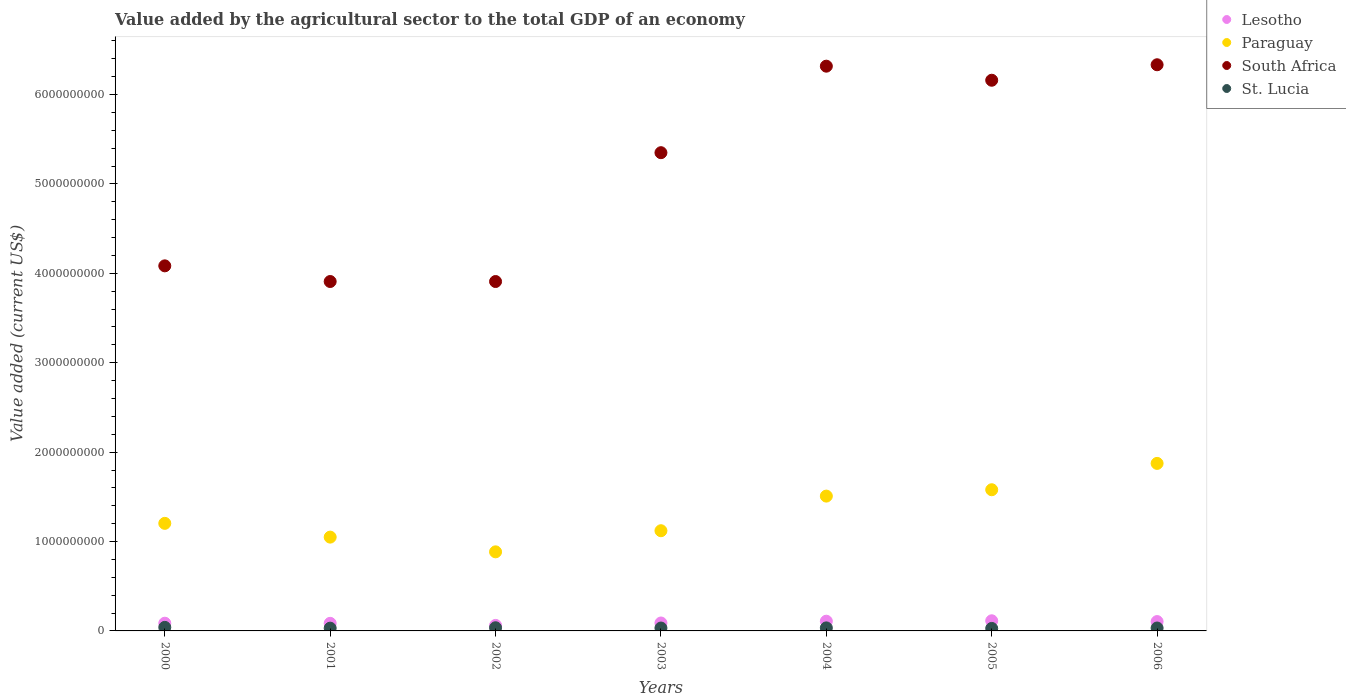Is the number of dotlines equal to the number of legend labels?
Give a very brief answer. Yes. What is the value added by the agricultural sector to the total GDP in St. Lucia in 2003?
Ensure brevity in your answer.  3.23e+07. Across all years, what is the maximum value added by the agricultural sector to the total GDP in Lesotho?
Provide a succinct answer. 1.13e+08. Across all years, what is the minimum value added by the agricultural sector to the total GDP in Lesotho?
Ensure brevity in your answer.  6.17e+07. What is the total value added by the agricultural sector to the total GDP in St. Lucia in the graph?
Keep it short and to the point. 2.33e+08. What is the difference between the value added by the agricultural sector to the total GDP in Lesotho in 2002 and that in 2005?
Your answer should be compact. -5.17e+07. What is the difference between the value added by the agricultural sector to the total GDP in Lesotho in 2002 and the value added by the agricultural sector to the total GDP in Paraguay in 2001?
Offer a terse response. -9.88e+08. What is the average value added by the agricultural sector to the total GDP in Lesotho per year?
Your answer should be very brief. 9.26e+07. In the year 2006, what is the difference between the value added by the agricultural sector to the total GDP in St. Lucia and value added by the agricultural sector to the total GDP in Lesotho?
Provide a short and direct response. -7.21e+07. In how many years, is the value added by the agricultural sector to the total GDP in Lesotho greater than 400000000 US$?
Provide a short and direct response. 0. What is the ratio of the value added by the agricultural sector to the total GDP in Lesotho in 2002 to that in 2003?
Offer a terse response. 0.7. What is the difference between the highest and the second highest value added by the agricultural sector to the total GDP in Paraguay?
Make the answer very short. 2.95e+08. What is the difference between the highest and the lowest value added by the agricultural sector to the total GDP in St. Lucia?
Your answer should be compact. 1.18e+07. In how many years, is the value added by the agricultural sector to the total GDP in St. Lucia greater than the average value added by the agricultural sector to the total GDP in St. Lucia taken over all years?
Make the answer very short. 3. Is the sum of the value added by the agricultural sector to the total GDP in St. Lucia in 2003 and 2006 greater than the maximum value added by the agricultural sector to the total GDP in South Africa across all years?
Keep it short and to the point. No. Is the value added by the agricultural sector to the total GDP in South Africa strictly less than the value added by the agricultural sector to the total GDP in Lesotho over the years?
Your answer should be compact. No. How many dotlines are there?
Your response must be concise. 4. Are the values on the major ticks of Y-axis written in scientific E-notation?
Keep it short and to the point. No. Does the graph contain grids?
Make the answer very short. No. What is the title of the graph?
Ensure brevity in your answer.  Value added by the agricultural sector to the total GDP of an economy. Does "Angola" appear as one of the legend labels in the graph?
Offer a terse response. No. What is the label or title of the Y-axis?
Offer a very short reply. Value added (current US$). What is the Value added (current US$) of Lesotho in 2000?
Provide a short and direct response. 8.62e+07. What is the Value added (current US$) of Paraguay in 2000?
Keep it short and to the point. 1.20e+09. What is the Value added (current US$) of South Africa in 2000?
Offer a terse response. 4.08e+09. What is the Value added (current US$) of St. Lucia in 2000?
Make the answer very short. 3.98e+07. What is the Value added (current US$) of Lesotho in 2001?
Provide a short and direct response. 8.49e+07. What is the Value added (current US$) of Paraguay in 2001?
Offer a terse response. 1.05e+09. What is the Value added (current US$) of South Africa in 2001?
Provide a succinct answer. 3.91e+09. What is the Value added (current US$) of St. Lucia in 2001?
Give a very brief answer. 3.09e+07. What is the Value added (current US$) in Lesotho in 2002?
Keep it short and to the point. 6.17e+07. What is the Value added (current US$) in Paraguay in 2002?
Your answer should be compact. 8.85e+08. What is the Value added (current US$) of South Africa in 2002?
Offer a terse response. 3.91e+09. What is the Value added (current US$) of St. Lucia in 2002?
Give a very brief answer. 3.55e+07. What is the Value added (current US$) in Lesotho in 2003?
Give a very brief answer. 8.87e+07. What is the Value added (current US$) of Paraguay in 2003?
Provide a short and direct response. 1.12e+09. What is the Value added (current US$) in South Africa in 2003?
Ensure brevity in your answer.  5.35e+09. What is the Value added (current US$) of St. Lucia in 2003?
Keep it short and to the point. 3.23e+07. What is the Value added (current US$) of Lesotho in 2004?
Offer a very short reply. 1.09e+08. What is the Value added (current US$) in Paraguay in 2004?
Offer a terse response. 1.51e+09. What is the Value added (current US$) of South Africa in 2004?
Your response must be concise. 6.32e+09. What is the Value added (current US$) of St. Lucia in 2004?
Your answer should be very brief. 3.39e+07. What is the Value added (current US$) in Lesotho in 2005?
Provide a short and direct response. 1.13e+08. What is the Value added (current US$) in Paraguay in 2005?
Provide a succinct answer. 1.58e+09. What is the Value added (current US$) in South Africa in 2005?
Give a very brief answer. 6.16e+09. What is the Value added (current US$) in St. Lucia in 2005?
Your answer should be very brief. 2.80e+07. What is the Value added (current US$) in Lesotho in 2006?
Make the answer very short. 1.05e+08. What is the Value added (current US$) in Paraguay in 2006?
Give a very brief answer. 1.87e+09. What is the Value added (current US$) in South Africa in 2006?
Provide a short and direct response. 6.33e+09. What is the Value added (current US$) of St. Lucia in 2006?
Give a very brief answer. 3.25e+07. Across all years, what is the maximum Value added (current US$) of Lesotho?
Your answer should be very brief. 1.13e+08. Across all years, what is the maximum Value added (current US$) in Paraguay?
Offer a terse response. 1.87e+09. Across all years, what is the maximum Value added (current US$) in South Africa?
Keep it short and to the point. 6.33e+09. Across all years, what is the maximum Value added (current US$) of St. Lucia?
Give a very brief answer. 3.98e+07. Across all years, what is the minimum Value added (current US$) of Lesotho?
Provide a short and direct response. 6.17e+07. Across all years, what is the minimum Value added (current US$) in Paraguay?
Offer a very short reply. 8.85e+08. Across all years, what is the minimum Value added (current US$) in South Africa?
Offer a very short reply. 3.91e+09. Across all years, what is the minimum Value added (current US$) of St. Lucia?
Ensure brevity in your answer.  2.80e+07. What is the total Value added (current US$) in Lesotho in the graph?
Give a very brief answer. 6.48e+08. What is the total Value added (current US$) of Paraguay in the graph?
Make the answer very short. 9.22e+09. What is the total Value added (current US$) of South Africa in the graph?
Provide a succinct answer. 3.61e+1. What is the total Value added (current US$) in St. Lucia in the graph?
Your answer should be compact. 2.33e+08. What is the difference between the Value added (current US$) of Lesotho in 2000 and that in 2001?
Your answer should be very brief. 1.31e+06. What is the difference between the Value added (current US$) in Paraguay in 2000 and that in 2001?
Keep it short and to the point. 1.54e+08. What is the difference between the Value added (current US$) of South Africa in 2000 and that in 2001?
Your answer should be very brief. 1.75e+08. What is the difference between the Value added (current US$) of St. Lucia in 2000 and that in 2001?
Keep it short and to the point. 8.83e+06. What is the difference between the Value added (current US$) of Lesotho in 2000 and that in 2002?
Make the answer very short. 2.46e+07. What is the difference between the Value added (current US$) in Paraguay in 2000 and that in 2002?
Make the answer very short. 3.19e+08. What is the difference between the Value added (current US$) of South Africa in 2000 and that in 2002?
Provide a succinct answer. 1.75e+08. What is the difference between the Value added (current US$) of St. Lucia in 2000 and that in 2002?
Give a very brief answer. 4.28e+06. What is the difference between the Value added (current US$) of Lesotho in 2000 and that in 2003?
Keep it short and to the point. -2.48e+06. What is the difference between the Value added (current US$) of Paraguay in 2000 and that in 2003?
Your answer should be very brief. 8.25e+07. What is the difference between the Value added (current US$) of South Africa in 2000 and that in 2003?
Ensure brevity in your answer.  -1.27e+09. What is the difference between the Value added (current US$) of St. Lucia in 2000 and that in 2003?
Your answer should be compact. 7.50e+06. What is the difference between the Value added (current US$) of Lesotho in 2000 and that in 2004?
Give a very brief answer. -2.25e+07. What is the difference between the Value added (current US$) in Paraguay in 2000 and that in 2004?
Keep it short and to the point. -3.05e+08. What is the difference between the Value added (current US$) of South Africa in 2000 and that in 2004?
Your answer should be compact. -2.23e+09. What is the difference between the Value added (current US$) in St. Lucia in 2000 and that in 2004?
Give a very brief answer. 5.85e+06. What is the difference between the Value added (current US$) in Lesotho in 2000 and that in 2005?
Your response must be concise. -2.72e+07. What is the difference between the Value added (current US$) of Paraguay in 2000 and that in 2005?
Make the answer very short. -3.76e+08. What is the difference between the Value added (current US$) in South Africa in 2000 and that in 2005?
Provide a succinct answer. -2.08e+09. What is the difference between the Value added (current US$) in St. Lucia in 2000 and that in 2005?
Your response must be concise. 1.18e+07. What is the difference between the Value added (current US$) of Lesotho in 2000 and that in 2006?
Provide a succinct answer. -1.84e+07. What is the difference between the Value added (current US$) in Paraguay in 2000 and that in 2006?
Provide a succinct answer. -6.71e+08. What is the difference between the Value added (current US$) in South Africa in 2000 and that in 2006?
Your answer should be compact. -2.25e+09. What is the difference between the Value added (current US$) of St. Lucia in 2000 and that in 2006?
Your response must be concise. 7.23e+06. What is the difference between the Value added (current US$) in Lesotho in 2001 and that in 2002?
Ensure brevity in your answer.  2.32e+07. What is the difference between the Value added (current US$) in Paraguay in 2001 and that in 2002?
Provide a short and direct response. 1.65e+08. What is the difference between the Value added (current US$) in South Africa in 2001 and that in 2002?
Keep it short and to the point. 5.74e+04. What is the difference between the Value added (current US$) in St. Lucia in 2001 and that in 2002?
Ensure brevity in your answer.  -4.55e+06. What is the difference between the Value added (current US$) in Lesotho in 2001 and that in 2003?
Your answer should be very brief. -3.79e+06. What is the difference between the Value added (current US$) of Paraguay in 2001 and that in 2003?
Offer a terse response. -7.15e+07. What is the difference between the Value added (current US$) in South Africa in 2001 and that in 2003?
Offer a very short reply. -1.44e+09. What is the difference between the Value added (current US$) of St. Lucia in 2001 and that in 2003?
Make the answer very short. -1.34e+06. What is the difference between the Value added (current US$) in Lesotho in 2001 and that in 2004?
Make the answer very short. -2.38e+07. What is the difference between the Value added (current US$) in Paraguay in 2001 and that in 2004?
Your answer should be compact. -4.59e+08. What is the difference between the Value added (current US$) of South Africa in 2001 and that in 2004?
Give a very brief answer. -2.41e+09. What is the difference between the Value added (current US$) in St. Lucia in 2001 and that in 2004?
Provide a succinct answer. -2.99e+06. What is the difference between the Value added (current US$) in Lesotho in 2001 and that in 2005?
Your response must be concise. -2.85e+07. What is the difference between the Value added (current US$) of Paraguay in 2001 and that in 2005?
Provide a short and direct response. -5.30e+08. What is the difference between the Value added (current US$) in South Africa in 2001 and that in 2005?
Ensure brevity in your answer.  -2.25e+09. What is the difference between the Value added (current US$) in St. Lucia in 2001 and that in 2005?
Provide a short and direct response. 2.96e+06. What is the difference between the Value added (current US$) of Lesotho in 2001 and that in 2006?
Your answer should be very brief. -1.97e+07. What is the difference between the Value added (current US$) in Paraguay in 2001 and that in 2006?
Ensure brevity in your answer.  -8.25e+08. What is the difference between the Value added (current US$) of South Africa in 2001 and that in 2006?
Keep it short and to the point. -2.42e+09. What is the difference between the Value added (current US$) in St. Lucia in 2001 and that in 2006?
Provide a short and direct response. -1.60e+06. What is the difference between the Value added (current US$) in Lesotho in 2002 and that in 2003?
Offer a terse response. -2.70e+07. What is the difference between the Value added (current US$) of Paraguay in 2002 and that in 2003?
Provide a succinct answer. -2.36e+08. What is the difference between the Value added (current US$) in South Africa in 2002 and that in 2003?
Keep it short and to the point. -1.44e+09. What is the difference between the Value added (current US$) in St. Lucia in 2002 and that in 2003?
Provide a short and direct response. 3.22e+06. What is the difference between the Value added (current US$) of Lesotho in 2002 and that in 2004?
Your answer should be very brief. -4.70e+07. What is the difference between the Value added (current US$) of Paraguay in 2002 and that in 2004?
Offer a very short reply. -6.23e+08. What is the difference between the Value added (current US$) in South Africa in 2002 and that in 2004?
Give a very brief answer. -2.41e+09. What is the difference between the Value added (current US$) in St. Lucia in 2002 and that in 2004?
Provide a short and direct response. 1.57e+06. What is the difference between the Value added (current US$) in Lesotho in 2002 and that in 2005?
Keep it short and to the point. -5.17e+07. What is the difference between the Value added (current US$) in Paraguay in 2002 and that in 2005?
Make the answer very short. -6.95e+08. What is the difference between the Value added (current US$) of South Africa in 2002 and that in 2005?
Give a very brief answer. -2.25e+09. What is the difference between the Value added (current US$) in St. Lucia in 2002 and that in 2005?
Provide a short and direct response. 7.51e+06. What is the difference between the Value added (current US$) in Lesotho in 2002 and that in 2006?
Your answer should be compact. -4.30e+07. What is the difference between the Value added (current US$) of Paraguay in 2002 and that in 2006?
Make the answer very short. -9.89e+08. What is the difference between the Value added (current US$) of South Africa in 2002 and that in 2006?
Make the answer very short. -2.42e+09. What is the difference between the Value added (current US$) of St. Lucia in 2002 and that in 2006?
Your answer should be very brief. 2.95e+06. What is the difference between the Value added (current US$) of Lesotho in 2003 and that in 2004?
Your answer should be compact. -2.00e+07. What is the difference between the Value added (current US$) in Paraguay in 2003 and that in 2004?
Your answer should be very brief. -3.87e+08. What is the difference between the Value added (current US$) in South Africa in 2003 and that in 2004?
Offer a very short reply. -9.68e+08. What is the difference between the Value added (current US$) in St. Lucia in 2003 and that in 2004?
Your answer should be very brief. -1.65e+06. What is the difference between the Value added (current US$) in Lesotho in 2003 and that in 2005?
Provide a succinct answer. -2.47e+07. What is the difference between the Value added (current US$) of Paraguay in 2003 and that in 2005?
Offer a very short reply. -4.58e+08. What is the difference between the Value added (current US$) of South Africa in 2003 and that in 2005?
Offer a terse response. -8.10e+08. What is the difference between the Value added (current US$) in St. Lucia in 2003 and that in 2005?
Your answer should be compact. 4.29e+06. What is the difference between the Value added (current US$) of Lesotho in 2003 and that in 2006?
Provide a short and direct response. -1.60e+07. What is the difference between the Value added (current US$) of Paraguay in 2003 and that in 2006?
Give a very brief answer. -7.53e+08. What is the difference between the Value added (current US$) in South Africa in 2003 and that in 2006?
Your answer should be compact. -9.84e+08. What is the difference between the Value added (current US$) in St. Lucia in 2003 and that in 2006?
Ensure brevity in your answer.  -2.67e+05. What is the difference between the Value added (current US$) of Lesotho in 2004 and that in 2005?
Keep it short and to the point. -4.70e+06. What is the difference between the Value added (current US$) in Paraguay in 2004 and that in 2005?
Ensure brevity in your answer.  -7.11e+07. What is the difference between the Value added (current US$) of South Africa in 2004 and that in 2005?
Your answer should be very brief. 1.57e+08. What is the difference between the Value added (current US$) of St. Lucia in 2004 and that in 2005?
Give a very brief answer. 5.94e+06. What is the difference between the Value added (current US$) in Lesotho in 2004 and that in 2006?
Provide a short and direct response. 4.02e+06. What is the difference between the Value added (current US$) in Paraguay in 2004 and that in 2006?
Make the answer very short. -3.66e+08. What is the difference between the Value added (current US$) of South Africa in 2004 and that in 2006?
Offer a terse response. -1.58e+07. What is the difference between the Value added (current US$) of St. Lucia in 2004 and that in 2006?
Give a very brief answer. 1.38e+06. What is the difference between the Value added (current US$) in Lesotho in 2005 and that in 2006?
Offer a very short reply. 8.72e+06. What is the difference between the Value added (current US$) of Paraguay in 2005 and that in 2006?
Make the answer very short. -2.95e+08. What is the difference between the Value added (current US$) of South Africa in 2005 and that in 2006?
Provide a short and direct response. -1.73e+08. What is the difference between the Value added (current US$) of St. Lucia in 2005 and that in 2006?
Provide a short and direct response. -4.56e+06. What is the difference between the Value added (current US$) in Lesotho in 2000 and the Value added (current US$) in Paraguay in 2001?
Offer a very short reply. -9.63e+08. What is the difference between the Value added (current US$) in Lesotho in 2000 and the Value added (current US$) in South Africa in 2001?
Your answer should be very brief. -3.82e+09. What is the difference between the Value added (current US$) in Lesotho in 2000 and the Value added (current US$) in St. Lucia in 2001?
Provide a succinct answer. 5.53e+07. What is the difference between the Value added (current US$) of Paraguay in 2000 and the Value added (current US$) of South Africa in 2001?
Provide a succinct answer. -2.71e+09. What is the difference between the Value added (current US$) of Paraguay in 2000 and the Value added (current US$) of St. Lucia in 2001?
Keep it short and to the point. 1.17e+09. What is the difference between the Value added (current US$) in South Africa in 2000 and the Value added (current US$) in St. Lucia in 2001?
Offer a very short reply. 4.05e+09. What is the difference between the Value added (current US$) in Lesotho in 2000 and the Value added (current US$) in Paraguay in 2002?
Give a very brief answer. -7.98e+08. What is the difference between the Value added (current US$) of Lesotho in 2000 and the Value added (current US$) of South Africa in 2002?
Make the answer very short. -3.82e+09. What is the difference between the Value added (current US$) in Lesotho in 2000 and the Value added (current US$) in St. Lucia in 2002?
Your response must be concise. 5.07e+07. What is the difference between the Value added (current US$) in Paraguay in 2000 and the Value added (current US$) in South Africa in 2002?
Your answer should be very brief. -2.71e+09. What is the difference between the Value added (current US$) in Paraguay in 2000 and the Value added (current US$) in St. Lucia in 2002?
Your response must be concise. 1.17e+09. What is the difference between the Value added (current US$) of South Africa in 2000 and the Value added (current US$) of St. Lucia in 2002?
Make the answer very short. 4.05e+09. What is the difference between the Value added (current US$) of Lesotho in 2000 and the Value added (current US$) of Paraguay in 2003?
Your response must be concise. -1.03e+09. What is the difference between the Value added (current US$) in Lesotho in 2000 and the Value added (current US$) in South Africa in 2003?
Keep it short and to the point. -5.26e+09. What is the difference between the Value added (current US$) of Lesotho in 2000 and the Value added (current US$) of St. Lucia in 2003?
Keep it short and to the point. 5.39e+07. What is the difference between the Value added (current US$) in Paraguay in 2000 and the Value added (current US$) in South Africa in 2003?
Your answer should be compact. -4.15e+09. What is the difference between the Value added (current US$) in Paraguay in 2000 and the Value added (current US$) in St. Lucia in 2003?
Your answer should be compact. 1.17e+09. What is the difference between the Value added (current US$) in South Africa in 2000 and the Value added (current US$) in St. Lucia in 2003?
Make the answer very short. 4.05e+09. What is the difference between the Value added (current US$) of Lesotho in 2000 and the Value added (current US$) of Paraguay in 2004?
Your answer should be compact. -1.42e+09. What is the difference between the Value added (current US$) in Lesotho in 2000 and the Value added (current US$) in South Africa in 2004?
Offer a terse response. -6.23e+09. What is the difference between the Value added (current US$) of Lesotho in 2000 and the Value added (current US$) of St. Lucia in 2004?
Your response must be concise. 5.23e+07. What is the difference between the Value added (current US$) of Paraguay in 2000 and the Value added (current US$) of South Africa in 2004?
Your answer should be very brief. -5.11e+09. What is the difference between the Value added (current US$) of Paraguay in 2000 and the Value added (current US$) of St. Lucia in 2004?
Your answer should be very brief. 1.17e+09. What is the difference between the Value added (current US$) in South Africa in 2000 and the Value added (current US$) in St. Lucia in 2004?
Give a very brief answer. 4.05e+09. What is the difference between the Value added (current US$) in Lesotho in 2000 and the Value added (current US$) in Paraguay in 2005?
Offer a very short reply. -1.49e+09. What is the difference between the Value added (current US$) of Lesotho in 2000 and the Value added (current US$) of South Africa in 2005?
Your answer should be very brief. -6.07e+09. What is the difference between the Value added (current US$) of Lesotho in 2000 and the Value added (current US$) of St. Lucia in 2005?
Provide a short and direct response. 5.82e+07. What is the difference between the Value added (current US$) of Paraguay in 2000 and the Value added (current US$) of South Africa in 2005?
Your answer should be very brief. -4.96e+09. What is the difference between the Value added (current US$) in Paraguay in 2000 and the Value added (current US$) in St. Lucia in 2005?
Ensure brevity in your answer.  1.18e+09. What is the difference between the Value added (current US$) of South Africa in 2000 and the Value added (current US$) of St. Lucia in 2005?
Provide a succinct answer. 4.06e+09. What is the difference between the Value added (current US$) in Lesotho in 2000 and the Value added (current US$) in Paraguay in 2006?
Provide a succinct answer. -1.79e+09. What is the difference between the Value added (current US$) of Lesotho in 2000 and the Value added (current US$) of South Africa in 2006?
Offer a terse response. -6.25e+09. What is the difference between the Value added (current US$) of Lesotho in 2000 and the Value added (current US$) of St. Lucia in 2006?
Offer a very short reply. 5.37e+07. What is the difference between the Value added (current US$) of Paraguay in 2000 and the Value added (current US$) of South Africa in 2006?
Give a very brief answer. -5.13e+09. What is the difference between the Value added (current US$) of Paraguay in 2000 and the Value added (current US$) of St. Lucia in 2006?
Your response must be concise. 1.17e+09. What is the difference between the Value added (current US$) in South Africa in 2000 and the Value added (current US$) in St. Lucia in 2006?
Give a very brief answer. 4.05e+09. What is the difference between the Value added (current US$) in Lesotho in 2001 and the Value added (current US$) in Paraguay in 2002?
Provide a succinct answer. -8.00e+08. What is the difference between the Value added (current US$) in Lesotho in 2001 and the Value added (current US$) in South Africa in 2002?
Provide a short and direct response. -3.82e+09. What is the difference between the Value added (current US$) of Lesotho in 2001 and the Value added (current US$) of St. Lucia in 2002?
Provide a succinct answer. 4.94e+07. What is the difference between the Value added (current US$) of Paraguay in 2001 and the Value added (current US$) of South Africa in 2002?
Keep it short and to the point. -2.86e+09. What is the difference between the Value added (current US$) in Paraguay in 2001 and the Value added (current US$) in St. Lucia in 2002?
Your response must be concise. 1.01e+09. What is the difference between the Value added (current US$) of South Africa in 2001 and the Value added (current US$) of St. Lucia in 2002?
Offer a very short reply. 3.87e+09. What is the difference between the Value added (current US$) of Lesotho in 2001 and the Value added (current US$) of Paraguay in 2003?
Ensure brevity in your answer.  -1.04e+09. What is the difference between the Value added (current US$) of Lesotho in 2001 and the Value added (current US$) of South Africa in 2003?
Your answer should be very brief. -5.26e+09. What is the difference between the Value added (current US$) of Lesotho in 2001 and the Value added (current US$) of St. Lucia in 2003?
Ensure brevity in your answer.  5.26e+07. What is the difference between the Value added (current US$) of Paraguay in 2001 and the Value added (current US$) of South Africa in 2003?
Offer a terse response. -4.30e+09. What is the difference between the Value added (current US$) of Paraguay in 2001 and the Value added (current US$) of St. Lucia in 2003?
Make the answer very short. 1.02e+09. What is the difference between the Value added (current US$) of South Africa in 2001 and the Value added (current US$) of St. Lucia in 2003?
Give a very brief answer. 3.88e+09. What is the difference between the Value added (current US$) in Lesotho in 2001 and the Value added (current US$) in Paraguay in 2004?
Offer a terse response. -1.42e+09. What is the difference between the Value added (current US$) in Lesotho in 2001 and the Value added (current US$) in South Africa in 2004?
Ensure brevity in your answer.  -6.23e+09. What is the difference between the Value added (current US$) of Lesotho in 2001 and the Value added (current US$) of St. Lucia in 2004?
Your answer should be very brief. 5.10e+07. What is the difference between the Value added (current US$) of Paraguay in 2001 and the Value added (current US$) of South Africa in 2004?
Ensure brevity in your answer.  -5.27e+09. What is the difference between the Value added (current US$) in Paraguay in 2001 and the Value added (current US$) in St. Lucia in 2004?
Keep it short and to the point. 1.02e+09. What is the difference between the Value added (current US$) of South Africa in 2001 and the Value added (current US$) of St. Lucia in 2004?
Ensure brevity in your answer.  3.87e+09. What is the difference between the Value added (current US$) in Lesotho in 2001 and the Value added (current US$) in Paraguay in 2005?
Your answer should be compact. -1.49e+09. What is the difference between the Value added (current US$) in Lesotho in 2001 and the Value added (current US$) in South Africa in 2005?
Provide a short and direct response. -6.07e+09. What is the difference between the Value added (current US$) of Lesotho in 2001 and the Value added (current US$) of St. Lucia in 2005?
Your response must be concise. 5.69e+07. What is the difference between the Value added (current US$) in Paraguay in 2001 and the Value added (current US$) in South Africa in 2005?
Keep it short and to the point. -5.11e+09. What is the difference between the Value added (current US$) of Paraguay in 2001 and the Value added (current US$) of St. Lucia in 2005?
Keep it short and to the point. 1.02e+09. What is the difference between the Value added (current US$) in South Africa in 2001 and the Value added (current US$) in St. Lucia in 2005?
Give a very brief answer. 3.88e+09. What is the difference between the Value added (current US$) in Lesotho in 2001 and the Value added (current US$) in Paraguay in 2006?
Keep it short and to the point. -1.79e+09. What is the difference between the Value added (current US$) of Lesotho in 2001 and the Value added (current US$) of South Africa in 2006?
Provide a short and direct response. -6.25e+09. What is the difference between the Value added (current US$) of Lesotho in 2001 and the Value added (current US$) of St. Lucia in 2006?
Your answer should be very brief. 5.24e+07. What is the difference between the Value added (current US$) in Paraguay in 2001 and the Value added (current US$) in South Africa in 2006?
Offer a terse response. -5.28e+09. What is the difference between the Value added (current US$) in Paraguay in 2001 and the Value added (current US$) in St. Lucia in 2006?
Keep it short and to the point. 1.02e+09. What is the difference between the Value added (current US$) of South Africa in 2001 and the Value added (current US$) of St. Lucia in 2006?
Offer a terse response. 3.88e+09. What is the difference between the Value added (current US$) in Lesotho in 2002 and the Value added (current US$) in Paraguay in 2003?
Keep it short and to the point. -1.06e+09. What is the difference between the Value added (current US$) in Lesotho in 2002 and the Value added (current US$) in South Africa in 2003?
Your response must be concise. -5.29e+09. What is the difference between the Value added (current US$) of Lesotho in 2002 and the Value added (current US$) of St. Lucia in 2003?
Your answer should be very brief. 2.94e+07. What is the difference between the Value added (current US$) in Paraguay in 2002 and the Value added (current US$) in South Africa in 2003?
Make the answer very short. -4.46e+09. What is the difference between the Value added (current US$) in Paraguay in 2002 and the Value added (current US$) in St. Lucia in 2003?
Keep it short and to the point. 8.52e+08. What is the difference between the Value added (current US$) in South Africa in 2002 and the Value added (current US$) in St. Lucia in 2003?
Your answer should be very brief. 3.88e+09. What is the difference between the Value added (current US$) of Lesotho in 2002 and the Value added (current US$) of Paraguay in 2004?
Offer a terse response. -1.45e+09. What is the difference between the Value added (current US$) of Lesotho in 2002 and the Value added (current US$) of South Africa in 2004?
Ensure brevity in your answer.  -6.26e+09. What is the difference between the Value added (current US$) of Lesotho in 2002 and the Value added (current US$) of St. Lucia in 2004?
Your answer should be compact. 2.77e+07. What is the difference between the Value added (current US$) of Paraguay in 2002 and the Value added (current US$) of South Africa in 2004?
Ensure brevity in your answer.  -5.43e+09. What is the difference between the Value added (current US$) of Paraguay in 2002 and the Value added (current US$) of St. Lucia in 2004?
Provide a short and direct response. 8.51e+08. What is the difference between the Value added (current US$) of South Africa in 2002 and the Value added (current US$) of St. Lucia in 2004?
Your response must be concise. 3.87e+09. What is the difference between the Value added (current US$) in Lesotho in 2002 and the Value added (current US$) in Paraguay in 2005?
Provide a short and direct response. -1.52e+09. What is the difference between the Value added (current US$) in Lesotho in 2002 and the Value added (current US$) in South Africa in 2005?
Your response must be concise. -6.10e+09. What is the difference between the Value added (current US$) in Lesotho in 2002 and the Value added (current US$) in St. Lucia in 2005?
Your answer should be very brief. 3.37e+07. What is the difference between the Value added (current US$) of Paraguay in 2002 and the Value added (current US$) of South Africa in 2005?
Offer a very short reply. -5.28e+09. What is the difference between the Value added (current US$) of Paraguay in 2002 and the Value added (current US$) of St. Lucia in 2005?
Provide a short and direct response. 8.57e+08. What is the difference between the Value added (current US$) in South Africa in 2002 and the Value added (current US$) in St. Lucia in 2005?
Your answer should be compact. 3.88e+09. What is the difference between the Value added (current US$) in Lesotho in 2002 and the Value added (current US$) in Paraguay in 2006?
Your answer should be very brief. -1.81e+09. What is the difference between the Value added (current US$) of Lesotho in 2002 and the Value added (current US$) of South Africa in 2006?
Ensure brevity in your answer.  -6.27e+09. What is the difference between the Value added (current US$) of Lesotho in 2002 and the Value added (current US$) of St. Lucia in 2006?
Your answer should be very brief. 2.91e+07. What is the difference between the Value added (current US$) of Paraguay in 2002 and the Value added (current US$) of South Africa in 2006?
Provide a succinct answer. -5.45e+09. What is the difference between the Value added (current US$) of Paraguay in 2002 and the Value added (current US$) of St. Lucia in 2006?
Ensure brevity in your answer.  8.52e+08. What is the difference between the Value added (current US$) in South Africa in 2002 and the Value added (current US$) in St. Lucia in 2006?
Offer a very short reply. 3.88e+09. What is the difference between the Value added (current US$) of Lesotho in 2003 and the Value added (current US$) of Paraguay in 2004?
Your response must be concise. -1.42e+09. What is the difference between the Value added (current US$) in Lesotho in 2003 and the Value added (current US$) in South Africa in 2004?
Provide a succinct answer. -6.23e+09. What is the difference between the Value added (current US$) of Lesotho in 2003 and the Value added (current US$) of St. Lucia in 2004?
Provide a short and direct response. 5.48e+07. What is the difference between the Value added (current US$) in Paraguay in 2003 and the Value added (current US$) in South Africa in 2004?
Your response must be concise. -5.20e+09. What is the difference between the Value added (current US$) in Paraguay in 2003 and the Value added (current US$) in St. Lucia in 2004?
Your answer should be compact. 1.09e+09. What is the difference between the Value added (current US$) of South Africa in 2003 and the Value added (current US$) of St. Lucia in 2004?
Make the answer very short. 5.32e+09. What is the difference between the Value added (current US$) of Lesotho in 2003 and the Value added (current US$) of Paraguay in 2005?
Keep it short and to the point. -1.49e+09. What is the difference between the Value added (current US$) in Lesotho in 2003 and the Value added (current US$) in South Africa in 2005?
Your answer should be very brief. -6.07e+09. What is the difference between the Value added (current US$) in Lesotho in 2003 and the Value added (current US$) in St. Lucia in 2005?
Make the answer very short. 6.07e+07. What is the difference between the Value added (current US$) in Paraguay in 2003 and the Value added (current US$) in South Africa in 2005?
Ensure brevity in your answer.  -5.04e+09. What is the difference between the Value added (current US$) in Paraguay in 2003 and the Value added (current US$) in St. Lucia in 2005?
Keep it short and to the point. 1.09e+09. What is the difference between the Value added (current US$) in South Africa in 2003 and the Value added (current US$) in St. Lucia in 2005?
Your answer should be very brief. 5.32e+09. What is the difference between the Value added (current US$) of Lesotho in 2003 and the Value added (current US$) of Paraguay in 2006?
Ensure brevity in your answer.  -1.79e+09. What is the difference between the Value added (current US$) of Lesotho in 2003 and the Value added (current US$) of South Africa in 2006?
Offer a very short reply. -6.24e+09. What is the difference between the Value added (current US$) of Lesotho in 2003 and the Value added (current US$) of St. Lucia in 2006?
Your response must be concise. 5.62e+07. What is the difference between the Value added (current US$) in Paraguay in 2003 and the Value added (current US$) in South Africa in 2006?
Your answer should be compact. -5.21e+09. What is the difference between the Value added (current US$) in Paraguay in 2003 and the Value added (current US$) in St. Lucia in 2006?
Your response must be concise. 1.09e+09. What is the difference between the Value added (current US$) in South Africa in 2003 and the Value added (current US$) in St. Lucia in 2006?
Offer a terse response. 5.32e+09. What is the difference between the Value added (current US$) of Lesotho in 2004 and the Value added (current US$) of Paraguay in 2005?
Ensure brevity in your answer.  -1.47e+09. What is the difference between the Value added (current US$) in Lesotho in 2004 and the Value added (current US$) in South Africa in 2005?
Give a very brief answer. -6.05e+09. What is the difference between the Value added (current US$) in Lesotho in 2004 and the Value added (current US$) in St. Lucia in 2005?
Ensure brevity in your answer.  8.07e+07. What is the difference between the Value added (current US$) in Paraguay in 2004 and the Value added (current US$) in South Africa in 2005?
Provide a succinct answer. -4.65e+09. What is the difference between the Value added (current US$) in Paraguay in 2004 and the Value added (current US$) in St. Lucia in 2005?
Provide a short and direct response. 1.48e+09. What is the difference between the Value added (current US$) of South Africa in 2004 and the Value added (current US$) of St. Lucia in 2005?
Provide a succinct answer. 6.29e+09. What is the difference between the Value added (current US$) in Lesotho in 2004 and the Value added (current US$) in Paraguay in 2006?
Offer a terse response. -1.77e+09. What is the difference between the Value added (current US$) in Lesotho in 2004 and the Value added (current US$) in South Africa in 2006?
Provide a short and direct response. -6.22e+09. What is the difference between the Value added (current US$) of Lesotho in 2004 and the Value added (current US$) of St. Lucia in 2006?
Your answer should be very brief. 7.61e+07. What is the difference between the Value added (current US$) in Paraguay in 2004 and the Value added (current US$) in South Africa in 2006?
Ensure brevity in your answer.  -4.82e+09. What is the difference between the Value added (current US$) in Paraguay in 2004 and the Value added (current US$) in St. Lucia in 2006?
Offer a very short reply. 1.48e+09. What is the difference between the Value added (current US$) of South Africa in 2004 and the Value added (current US$) of St. Lucia in 2006?
Ensure brevity in your answer.  6.28e+09. What is the difference between the Value added (current US$) in Lesotho in 2005 and the Value added (current US$) in Paraguay in 2006?
Offer a very short reply. -1.76e+09. What is the difference between the Value added (current US$) in Lesotho in 2005 and the Value added (current US$) in South Africa in 2006?
Your answer should be compact. -6.22e+09. What is the difference between the Value added (current US$) of Lesotho in 2005 and the Value added (current US$) of St. Lucia in 2006?
Keep it short and to the point. 8.08e+07. What is the difference between the Value added (current US$) of Paraguay in 2005 and the Value added (current US$) of South Africa in 2006?
Offer a very short reply. -4.75e+09. What is the difference between the Value added (current US$) in Paraguay in 2005 and the Value added (current US$) in St. Lucia in 2006?
Your answer should be compact. 1.55e+09. What is the difference between the Value added (current US$) in South Africa in 2005 and the Value added (current US$) in St. Lucia in 2006?
Give a very brief answer. 6.13e+09. What is the average Value added (current US$) in Lesotho per year?
Your answer should be compact. 9.26e+07. What is the average Value added (current US$) in Paraguay per year?
Provide a succinct answer. 1.32e+09. What is the average Value added (current US$) in South Africa per year?
Give a very brief answer. 5.15e+09. What is the average Value added (current US$) of St. Lucia per year?
Ensure brevity in your answer.  3.33e+07. In the year 2000, what is the difference between the Value added (current US$) of Lesotho and Value added (current US$) of Paraguay?
Provide a short and direct response. -1.12e+09. In the year 2000, what is the difference between the Value added (current US$) in Lesotho and Value added (current US$) in South Africa?
Provide a succinct answer. -4.00e+09. In the year 2000, what is the difference between the Value added (current US$) in Lesotho and Value added (current US$) in St. Lucia?
Keep it short and to the point. 4.64e+07. In the year 2000, what is the difference between the Value added (current US$) of Paraguay and Value added (current US$) of South Africa?
Give a very brief answer. -2.88e+09. In the year 2000, what is the difference between the Value added (current US$) in Paraguay and Value added (current US$) in St. Lucia?
Your response must be concise. 1.16e+09. In the year 2000, what is the difference between the Value added (current US$) of South Africa and Value added (current US$) of St. Lucia?
Provide a short and direct response. 4.04e+09. In the year 2001, what is the difference between the Value added (current US$) in Lesotho and Value added (current US$) in Paraguay?
Your answer should be very brief. -9.64e+08. In the year 2001, what is the difference between the Value added (current US$) of Lesotho and Value added (current US$) of South Africa?
Provide a succinct answer. -3.82e+09. In the year 2001, what is the difference between the Value added (current US$) of Lesotho and Value added (current US$) of St. Lucia?
Ensure brevity in your answer.  5.40e+07. In the year 2001, what is the difference between the Value added (current US$) in Paraguay and Value added (current US$) in South Africa?
Keep it short and to the point. -2.86e+09. In the year 2001, what is the difference between the Value added (current US$) in Paraguay and Value added (current US$) in St. Lucia?
Provide a short and direct response. 1.02e+09. In the year 2001, what is the difference between the Value added (current US$) of South Africa and Value added (current US$) of St. Lucia?
Offer a very short reply. 3.88e+09. In the year 2002, what is the difference between the Value added (current US$) in Lesotho and Value added (current US$) in Paraguay?
Provide a succinct answer. -8.23e+08. In the year 2002, what is the difference between the Value added (current US$) of Lesotho and Value added (current US$) of South Africa?
Make the answer very short. -3.85e+09. In the year 2002, what is the difference between the Value added (current US$) in Lesotho and Value added (current US$) in St. Lucia?
Provide a short and direct response. 2.62e+07. In the year 2002, what is the difference between the Value added (current US$) in Paraguay and Value added (current US$) in South Africa?
Offer a terse response. -3.02e+09. In the year 2002, what is the difference between the Value added (current US$) in Paraguay and Value added (current US$) in St. Lucia?
Offer a terse response. 8.49e+08. In the year 2002, what is the difference between the Value added (current US$) in South Africa and Value added (current US$) in St. Lucia?
Ensure brevity in your answer.  3.87e+09. In the year 2003, what is the difference between the Value added (current US$) of Lesotho and Value added (current US$) of Paraguay?
Your answer should be compact. -1.03e+09. In the year 2003, what is the difference between the Value added (current US$) of Lesotho and Value added (current US$) of South Africa?
Provide a succinct answer. -5.26e+09. In the year 2003, what is the difference between the Value added (current US$) of Lesotho and Value added (current US$) of St. Lucia?
Ensure brevity in your answer.  5.64e+07. In the year 2003, what is the difference between the Value added (current US$) in Paraguay and Value added (current US$) in South Africa?
Provide a succinct answer. -4.23e+09. In the year 2003, what is the difference between the Value added (current US$) in Paraguay and Value added (current US$) in St. Lucia?
Keep it short and to the point. 1.09e+09. In the year 2003, what is the difference between the Value added (current US$) of South Africa and Value added (current US$) of St. Lucia?
Your answer should be compact. 5.32e+09. In the year 2004, what is the difference between the Value added (current US$) in Lesotho and Value added (current US$) in Paraguay?
Offer a very short reply. -1.40e+09. In the year 2004, what is the difference between the Value added (current US$) in Lesotho and Value added (current US$) in South Africa?
Provide a short and direct response. -6.21e+09. In the year 2004, what is the difference between the Value added (current US$) of Lesotho and Value added (current US$) of St. Lucia?
Keep it short and to the point. 7.47e+07. In the year 2004, what is the difference between the Value added (current US$) in Paraguay and Value added (current US$) in South Africa?
Ensure brevity in your answer.  -4.81e+09. In the year 2004, what is the difference between the Value added (current US$) of Paraguay and Value added (current US$) of St. Lucia?
Offer a very short reply. 1.47e+09. In the year 2004, what is the difference between the Value added (current US$) in South Africa and Value added (current US$) in St. Lucia?
Ensure brevity in your answer.  6.28e+09. In the year 2005, what is the difference between the Value added (current US$) in Lesotho and Value added (current US$) in Paraguay?
Offer a terse response. -1.47e+09. In the year 2005, what is the difference between the Value added (current US$) in Lesotho and Value added (current US$) in South Africa?
Ensure brevity in your answer.  -6.05e+09. In the year 2005, what is the difference between the Value added (current US$) of Lesotho and Value added (current US$) of St. Lucia?
Make the answer very short. 8.54e+07. In the year 2005, what is the difference between the Value added (current US$) in Paraguay and Value added (current US$) in South Africa?
Provide a succinct answer. -4.58e+09. In the year 2005, what is the difference between the Value added (current US$) of Paraguay and Value added (current US$) of St. Lucia?
Keep it short and to the point. 1.55e+09. In the year 2005, what is the difference between the Value added (current US$) of South Africa and Value added (current US$) of St. Lucia?
Provide a succinct answer. 6.13e+09. In the year 2006, what is the difference between the Value added (current US$) of Lesotho and Value added (current US$) of Paraguay?
Your answer should be very brief. -1.77e+09. In the year 2006, what is the difference between the Value added (current US$) of Lesotho and Value added (current US$) of South Africa?
Give a very brief answer. -6.23e+09. In the year 2006, what is the difference between the Value added (current US$) of Lesotho and Value added (current US$) of St. Lucia?
Give a very brief answer. 7.21e+07. In the year 2006, what is the difference between the Value added (current US$) of Paraguay and Value added (current US$) of South Africa?
Your answer should be very brief. -4.46e+09. In the year 2006, what is the difference between the Value added (current US$) in Paraguay and Value added (current US$) in St. Lucia?
Offer a terse response. 1.84e+09. In the year 2006, what is the difference between the Value added (current US$) of South Africa and Value added (current US$) of St. Lucia?
Offer a very short reply. 6.30e+09. What is the ratio of the Value added (current US$) in Lesotho in 2000 to that in 2001?
Offer a very short reply. 1.02. What is the ratio of the Value added (current US$) in Paraguay in 2000 to that in 2001?
Offer a very short reply. 1.15. What is the ratio of the Value added (current US$) of South Africa in 2000 to that in 2001?
Give a very brief answer. 1.04. What is the ratio of the Value added (current US$) of St. Lucia in 2000 to that in 2001?
Make the answer very short. 1.29. What is the ratio of the Value added (current US$) in Lesotho in 2000 to that in 2002?
Offer a terse response. 1.4. What is the ratio of the Value added (current US$) in Paraguay in 2000 to that in 2002?
Give a very brief answer. 1.36. What is the ratio of the Value added (current US$) of South Africa in 2000 to that in 2002?
Provide a short and direct response. 1.04. What is the ratio of the Value added (current US$) in St. Lucia in 2000 to that in 2002?
Ensure brevity in your answer.  1.12. What is the ratio of the Value added (current US$) of Lesotho in 2000 to that in 2003?
Provide a succinct answer. 0.97. What is the ratio of the Value added (current US$) of Paraguay in 2000 to that in 2003?
Keep it short and to the point. 1.07. What is the ratio of the Value added (current US$) in South Africa in 2000 to that in 2003?
Give a very brief answer. 0.76. What is the ratio of the Value added (current US$) of St. Lucia in 2000 to that in 2003?
Give a very brief answer. 1.23. What is the ratio of the Value added (current US$) in Lesotho in 2000 to that in 2004?
Provide a short and direct response. 0.79. What is the ratio of the Value added (current US$) of Paraguay in 2000 to that in 2004?
Offer a very short reply. 0.8. What is the ratio of the Value added (current US$) in South Africa in 2000 to that in 2004?
Provide a succinct answer. 0.65. What is the ratio of the Value added (current US$) in St. Lucia in 2000 to that in 2004?
Keep it short and to the point. 1.17. What is the ratio of the Value added (current US$) in Lesotho in 2000 to that in 2005?
Offer a terse response. 0.76. What is the ratio of the Value added (current US$) in Paraguay in 2000 to that in 2005?
Your answer should be very brief. 0.76. What is the ratio of the Value added (current US$) in South Africa in 2000 to that in 2005?
Ensure brevity in your answer.  0.66. What is the ratio of the Value added (current US$) of St. Lucia in 2000 to that in 2005?
Offer a terse response. 1.42. What is the ratio of the Value added (current US$) of Lesotho in 2000 to that in 2006?
Your answer should be compact. 0.82. What is the ratio of the Value added (current US$) in Paraguay in 2000 to that in 2006?
Ensure brevity in your answer.  0.64. What is the ratio of the Value added (current US$) of South Africa in 2000 to that in 2006?
Your answer should be very brief. 0.64. What is the ratio of the Value added (current US$) in St. Lucia in 2000 to that in 2006?
Provide a short and direct response. 1.22. What is the ratio of the Value added (current US$) in Lesotho in 2001 to that in 2002?
Offer a very short reply. 1.38. What is the ratio of the Value added (current US$) in Paraguay in 2001 to that in 2002?
Offer a terse response. 1.19. What is the ratio of the Value added (current US$) in South Africa in 2001 to that in 2002?
Provide a short and direct response. 1. What is the ratio of the Value added (current US$) of St. Lucia in 2001 to that in 2002?
Your answer should be compact. 0.87. What is the ratio of the Value added (current US$) of Lesotho in 2001 to that in 2003?
Offer a terse response. 0.96. What is the ratio of the Value added (current US$) in Paraguay in 2001 to that in 2003?
Your answer should be compact. 0.94. What is the ratio of the Value added (current US$) of South Africa in 2001 to that in 2003?
Your answer should be compact. 0.73. What is the ratio of the Value added (current US$) in St. Lucia in 2001 to that in 2003?
Your answer should be very brief. 0.96. What is the ratio of the Value added (current US$) in Lesotho in 2001 to that in 2004?
Give a very brief answer. 0.78. What is the ratio of the Value added (current US$) in Paraguay in 2001 to that in 2004?
Offer a very short reply. 0.7. What is the ratio of the Value added (current US$) in South Africa in 2001 to that in 2004?
Make the answer very short. 0.62. What is the ratio of the Value added (current US$) in St. Lucia in 2001 to that in 2004?
Offer a terse response. 0.91. What is the ratio of the Value added (current US$) of Lesotho in 2001 to that in 2005?
Your response must be concise. 0.75. What is the ratio of the Value added (current US$) of Paraguay in 2001 to that in 2005?
Ensure brevity in your answer.  0.66. What is the ratio of the Value added (current US$) of South Africa in 2001 to that in 2005?
Your answer should be very brief. 0.63. What is the ratio of the Value added (current US$) of St. Lucia in 2001 to that in 2005?
Give a very brief answer. 1.11. What is the ratio of the Value added (current US$) in Lesotho in 2001 to that in 2006?
Offer a terse response. 0.81. What is the ratio of the Value added (current US$) of Paraguay in 2001 to that in 2006?
Keep it short and to the point. 0.56. What is the ratio of the Value added (current US$) of South Africa in 2001 to that in 2006?
Make the answer very short. 0.62. What is the ratio of the Value added (current US$) of St. Lucia in 2001 to that in 2006?
Your response must be concise. 0.95. What is the ratio of the Value added (current US$) of Lesotho in 2002 to that in 2003?
Offer a terse response. 0.7. What is the ratio of the Value added (current US$) of Paraguay in 2002 to that in 2003?
Offer a terse response. 0.79. What is the ratio of the Value added (current US$) in South Africa in 2002 to that in 2003?
Offer a very short reply. 0.73. What is the ratio of the Value added (current US$) in St. Lucia in 2002 to that in 2003?
Your answer should be compact. 1.1. What is the ratio of the Value added (current US$) in Lesotho in 2002 to that in 2004?
Provide a short and direct response. 0.57. What is the ratio of the Value added (current US$) of Paraguay in 2002 to that in 2004?
Your answer should be compact. 0.59. What is the ratio of the Value added (current US$) of South Africa in 2002 to that in 2004?
Your response must be concise. 0.62. What is the ratio of the Value added (current US$) of St. Lucia in 2002 to that in 2004?
Offer a terse response. 1.05. What is the ratio of the Value added (current US$) in Lesotho in 2002 to that in 2005?
Your answer should be very brief. 0.54. What is the ratio of the Value added (current US$) of Paraguay in 2002 to that in 2005?
Offer a very short reply. 0.56. What is the ratio of the Value added (current US$) of South Africa in 2002 to that in 2005?
Make the answer very short. 0.63. What is the ratio of the Value added (current US$) of St. Lucia in 2002 to that in 2005?
Provide a succinct answer. 1.27. What is the ratio of the Value added (current US$) in Lesotho in 2002 to that in 2006?
Provide a succinct answer. 0.59. What is the ratio of the Value added (current US$) in Paraguay in 2002 to that in 2006?
Offer a terse response. 0.47. What is the ratio of the Value added (current US$) in South Africa in 2002 to that in 2006?
Your response must be concise. 0.62. What is the ratio of the Value added (current US$) in St. Lucia in 2002 to that in 2006?
Provide a succinct answer. 1.09. What is the ratio of the Value added (current US$) in Lesotho in 2003 to that in 2004?
Provide a succinct answer. 0.82. What is the ratio of the Value added (current US$) of Paraguay in 2003 to that in 2004?
Ensure brevity in your answer.  0.74. What is the ratio of the Value added (current US$) of South Africa in 2003 to that in 2004?
Your answer should be compact. 0.85. What is the ratio of the Value added (current US$) of St. Lucia in 2003 to that in 2004?
Provide a short and direct response. 0.95. What is the ratio of the Value added (current US$) in Lesotho in 2003 to that in 2005?
Your response must be concise. 0.78. What is the ratio of the Value added (current US$) of Paraguay in 2003 to that in 2005?
Ensure brevity in your answer.  0.71. What is the ratio of the Value added (current US$) of South Africa in 2003 to that in 2005?
Provide a succinct answer. 0.87. What is the ratio of the Value added (current US$) in St. Lucia in 2003 to that in 2005?
Ensure brevity in your answer.  1.15. What is the ratio of the Value added (current US$) of Lesotho in 2003 to that in 2006?
Provide a succinct answer. 0.85. What is the ratio of the Value added (current US$) in Paraguay in 2003 to that in 2006?
Provide a short and direct response. 0.6. What is the ratio of the Value added (current US$) of South Africa in 2003 to that in 2006?
Provide a short and direct response. 0.84. What is the ratio of the Value added (current US$) of Lesotho in 2004 to that in 2005?
Give a very brief answer. 0.96. What is the ratio of the Value added (current US$) of Paraguay in 2004 to that in 2005?
Provide a succinct answer. 0.95. What is the ratio of the Value added (current US$) in South Africa in 2004 to that in 2005?
Ensure brevity in your answer.  1.03. What is the ratio of the Value added (current US$) in St. Lucia in 2004 to that in 2005?
Ensure brevity in your answer.  1.21. What is the ratio of the Value added (current US$) in Lesotho in 2004 to that in 2006?
Your response must be concise. 1.04. What is the ratio of the Value added (current US$) of Paraguay in 2004 to that in 2006?
Offer a terse response. 0.8. What is the ratio of the Value added (current US$) in St. Lucia in 2004 to that in 2006?
Give a very brief answer. 1.04. What is the ratio of the Value added (current US$) of Lesotho in 2005 to that in 2006?
Your answer should be very brief. 1.08. What is the ratio of the Value added (current US$) in Paraguay in 2005 to that in 2006?
Give a very brief answer. 0.84. What is the ratio of the Value added (current US$) in South Africa in 2005 to that in 2006?
Your answer should be very brief. 0.97. What is the ratio of the Value added (current US$) in St. Lucia in 2005 to that in 2006?
Your answer should be very brief. 0.86. What is the difference between the highest and the second highest Value added (current US$) in Lesotho?
Keep it short and to the point. 4.70e+06. What is the difference between the highest and the second highest Value added (current US$) of Paraguay?
Make the answer very short. 2.95e+08. What is the difference between the highest and the second highest Value added (current US$) in South Africa?
Your answer should be very brief. 1.58e+07. What is the difference between the highest and the second highest Value added (current US$) in St. Lucia?
Make the answer very short. 4.28e+06. What is the difference between the highest and the lowest Value added (current US$) in Lesotho?
Your response must be concise. 5.17e+07. What is the difference between the highest and the lowest Value added (current US$) of Paraguay?
Offer a very short reply. 9.89e+08. What is the difference between the highest and the lowest Value added (current US$) in South Africa?
Provide a succinct answer. 2.42e+09. What is the difference between the highest and the lowest Value added (current US$) of St. Lucia?
Your response must be concise. 1.18e+07. 